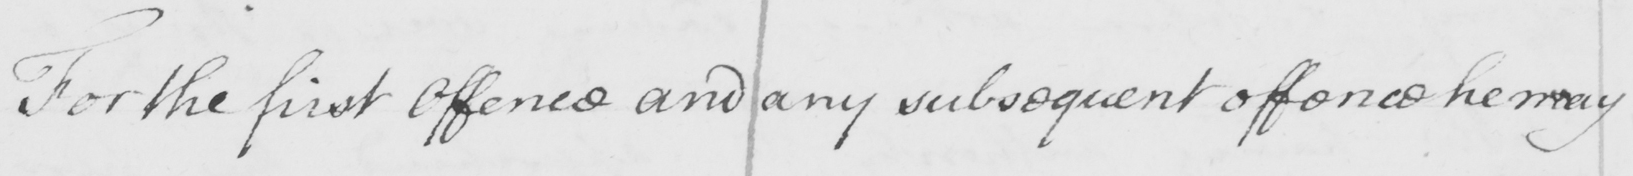Transcribe the text shown in this historical manuscript line. For the first Offence and any subsequent offence he may 